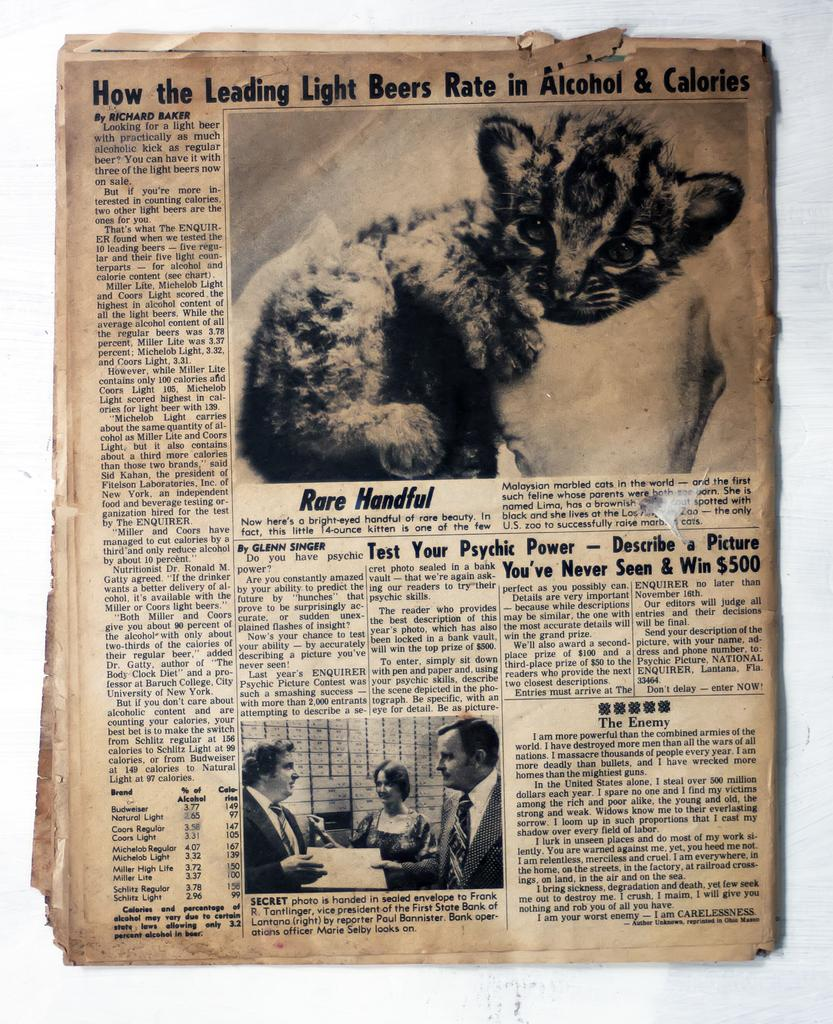What is the main subject of the image? The main subject of the image is a picture of a newspaper. What can be found within the newspaper? The newspaper contains text. What other image is present in the newspaper? There is an image of a person hand holding a cat in the image. Are there any other people depicted in the image? Yes, there is a picture of three people at the bottom of the image. What type of brush is being used to paint the weight on the newspaper? There is no brush or painting activity depicted in the image; it only contains a picture of a newspaper with an image of a person hand holding a cat and a picture of three people at the bottom. 